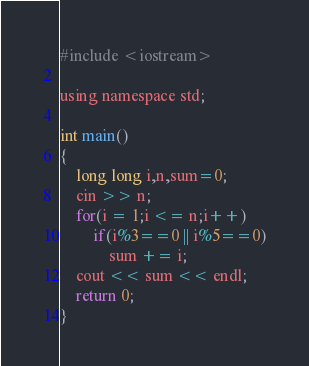Convert code to text. <code><loc_0><loc_0><loc_500><loc_500><_C_>#include <iostream>

using namespace std;

int main()
{
    long long i,n,sum=0;
    cin >> n;
    for(i = 1;i <= n;i++)
        if(i%3==0 || i%5==0)
            sum += i;
    cout << sum << endl;
    return 0;
}</code> 